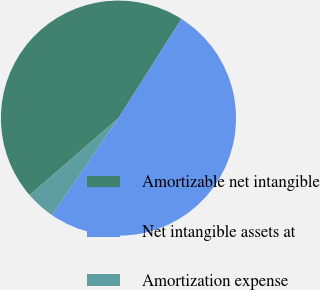Convert chart. <chart><loc_0><loc_0><loc_500><loc_500><pie_chart><fcel>Amortizable net intangible<fcel>Net intangible assets at<fcel>Amortization expense<nl><fcel>45.36%<fcel>50.56%<fcel>4.08%<nl></chart> 